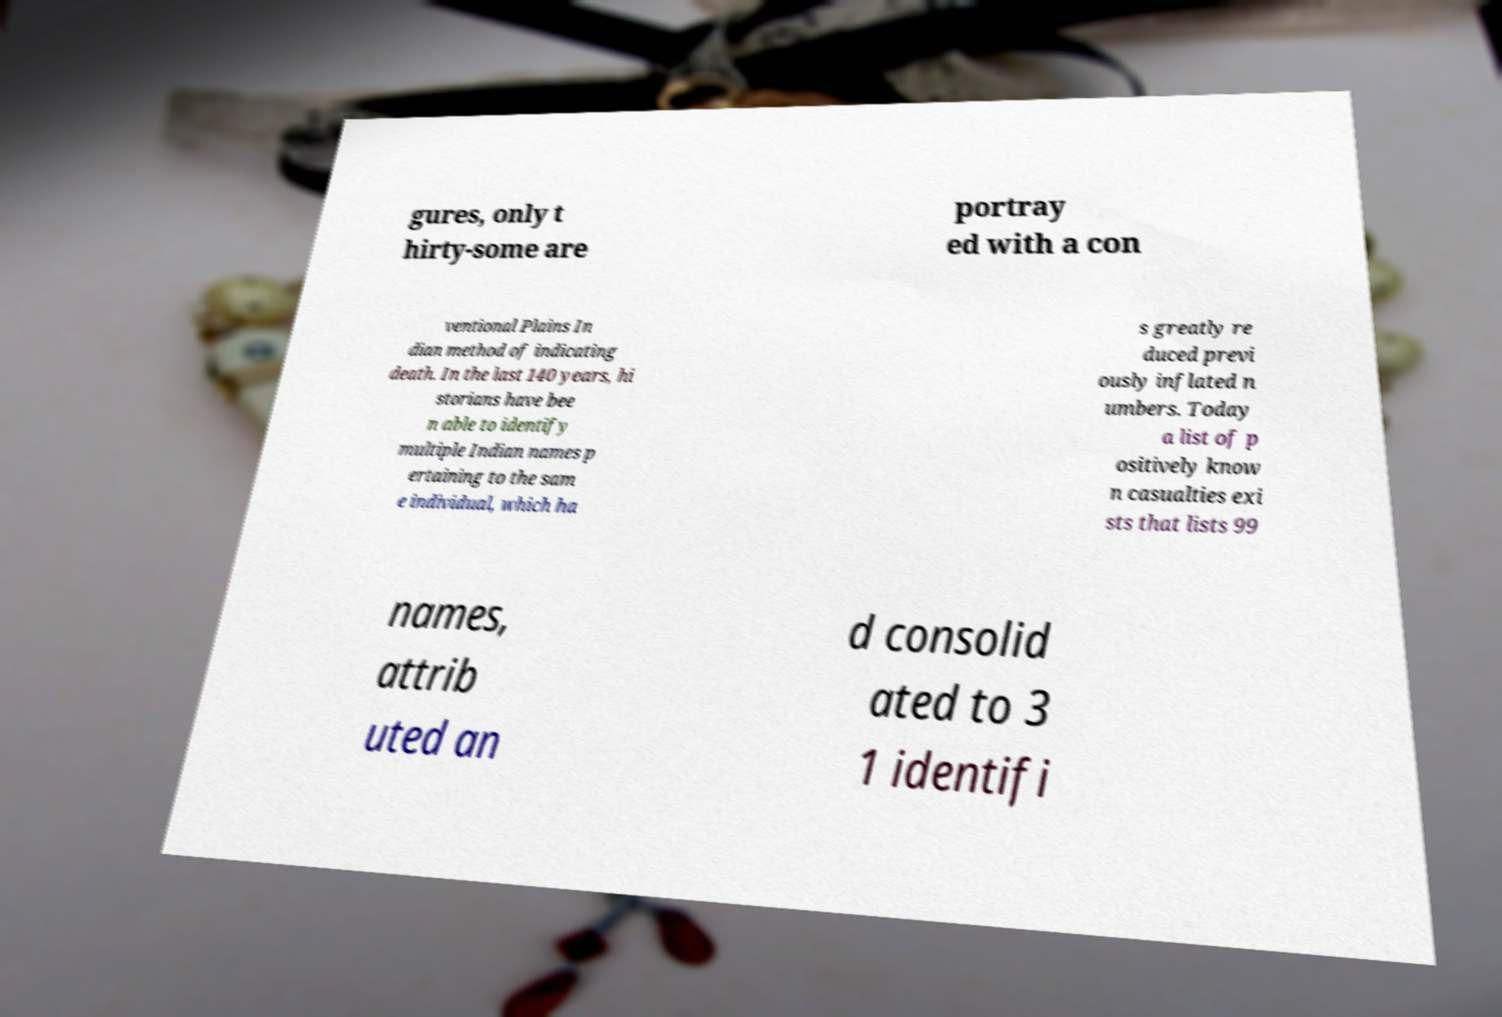I need the written content from this picture converted into text. Can you do that? gures, only t hirty-some are portray ed with a con ventional Plains In dian method of indicating death. In the last 140 years, hi storians have bee n able to identify multiple Indian names p ertaining to the sam e individual, which ha s greatly re duced previ ously inflated n umbers. Today a list of p ositively know n casualties exi sts that lists 99 names, attrib uted an d consolid ated to 3 1 identifi 